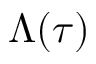Convert formula to latex. <formula><loc_0><loc_0><loc_500><loc_500>\Lambda ( \tau )</formula> 